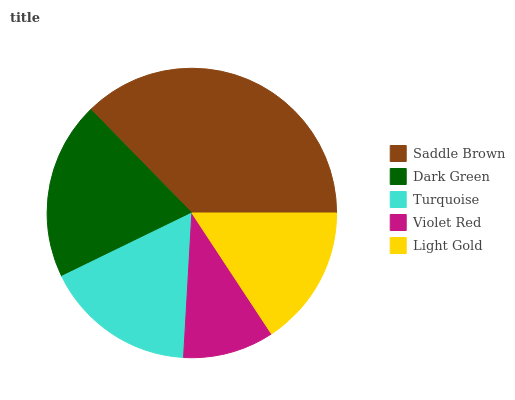Is Violet Red the minimum?
Answer yes or no. Yes. Is Saddle Brown the maximum?
Answer yes or no. Yes. Is Dark Green the minimum?
Answer yes or no. No. Is Dark Green the maximum?
Answer yes or no. No. Is Saddle Brown greater than Dark Green?
Answer yes or no. Yes. Is Dark Green less than Saddle Brown?
Answer yes or no. Yes. Is Dark Green greater than Saddle Brown?
Answer yes or no. No. Is Saddle Brown less than Dark Green?
Answer yes or no. No. Is Turquoise the high median?
Answer yes or no. Yes. Is Turquoise the low median?
Answer yes or no. Yes. Is Dark Green the high median?
Answer yes or no. No. Is Dark Green the low median?
Answer yes or no. No. 